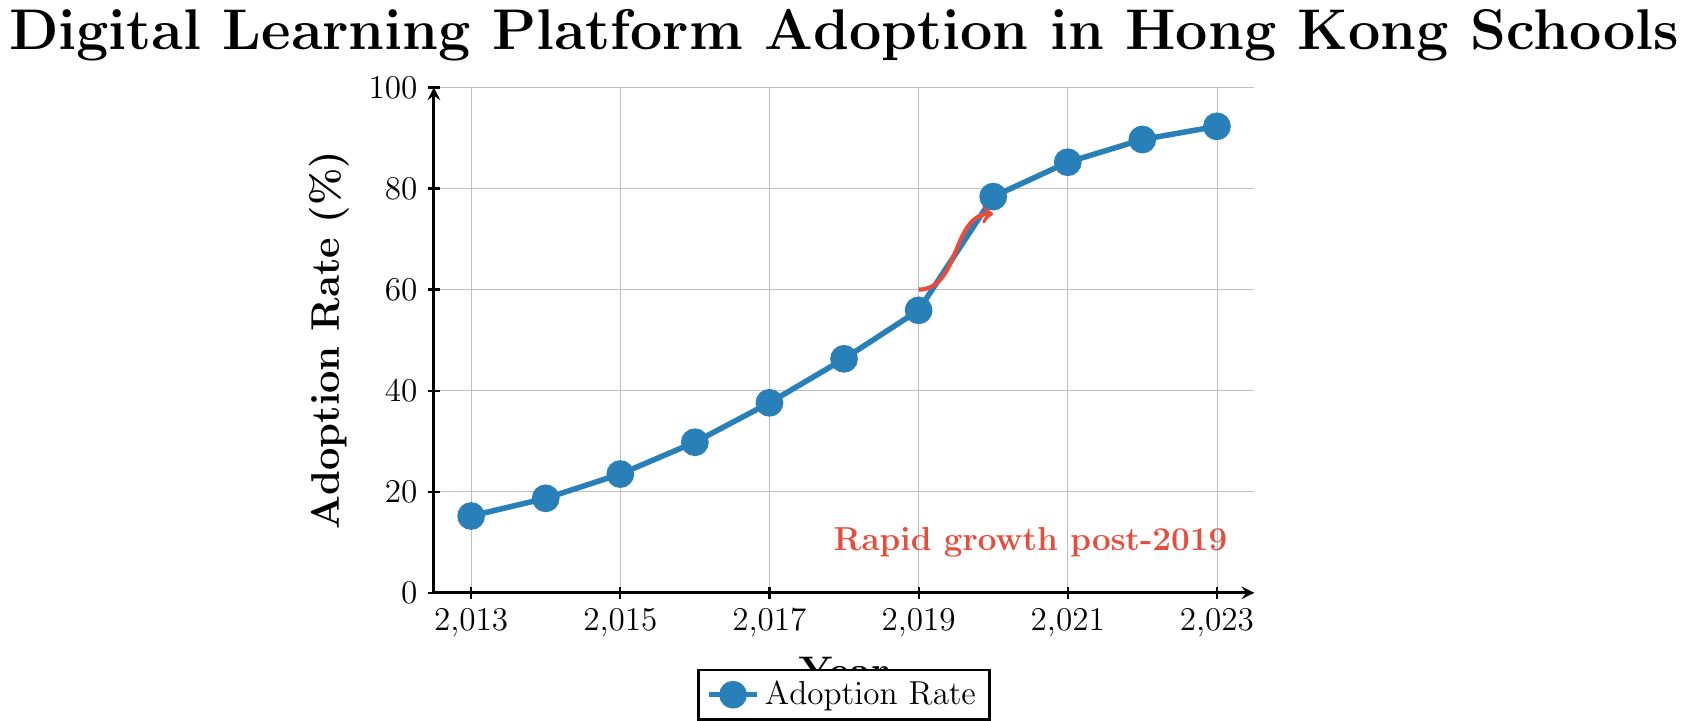What's the adoption rate of digital learning platforms in 2019? Locate the point for the year 2019 on the x-axis and read the corresponding value on the y-axis, which shows the adoption rate.
Answer: 55.9% In which year did the adoption rate first exceed 50%? Find the year where the adoption rate on the y-axis first goes above 50%. This occurs immediately after the year 2018.
Answer: 2019 How much did the adoption rate increase from 2013 to 2023? Subtract the adoption rate in 2013 from that in 2023: 92.3% - 15.2%.
Answer: 77.1% What is the average adoption rate from 2013 to 2023? Add all adoption rates from 2013 to 2023 and then divide by the number of years (11): (15.2 + 18.7 + 23.5 + 29.8 + 37.6 + 46.3 + 55.9 + 78.4 + 85.2 + 89.7 + 92.3) / 11.
Answer: 51.84% Between which two consecutive years was the highest growth in adoption rate observed? Calculate the differences between consecutive years and find the maximum: 
(2014-2013: 3.5, 2015-2014: 4.8, 2016-2015: 6.3, 2017-2016: 7.8, 2018-2017: 8.7, 2019-2018: 9.6, 2020-2019: 22.5, 2021-2020: 6.8, 2022-2021: 4.5, 2023-2022: 2.6). The highest difference (22.5) is between 2019 and 2020.
Answer: 2019 and 2020 What is the slope of the line between 2019 and 2020? Use the formula for slope: (y2 - y1) / (x2 - x1), where y2 = 78.4, y1 = 55.9, x2 = 2020, x1 = 2019. So, (78.4 - 55.9) / (2020 - 2019).
Answer: 22.5 How does the adoption rate in 2023 compare to 2017? Compare the adoption rates for the years 2023 and 2017: 92.3% vs. 37.6%.
Answer: 2023 rate is much higher What visual feature highlights the rapid growth post-2019? Look for annotations or arrows in the chart indicating significant trends. There's an annotation and arrow showing "Rapid growth post-2019."
Answer: An annotation and arrow What is the median adoption rate between 2013 and 2023? List all the adoption rates in increasing order and find the middle value:
15.2, 18.7, 23.5, 29.8, 37.6, 46.3, 55.9, 78.4, 85.2, 89.7, 92.3. The median (middle) value is the 6th value, 46.3.
Answer: 46.3% 